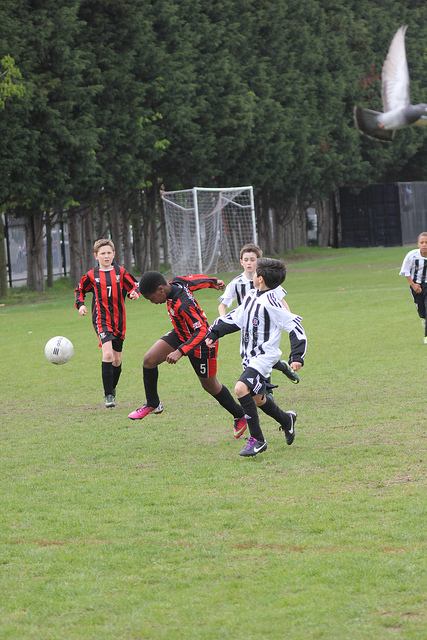Extract all visible text content from this image. 5 